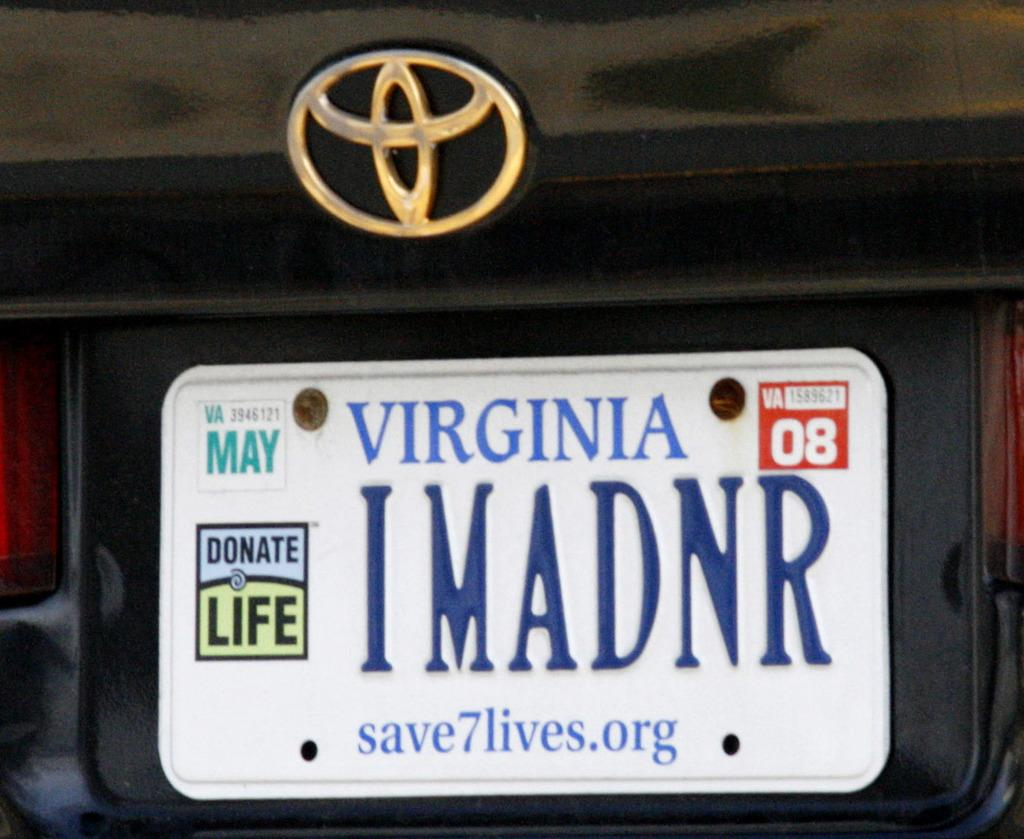<image>
Summarize the visual content of the image. a white license plate for Virginia reads IMADNR 